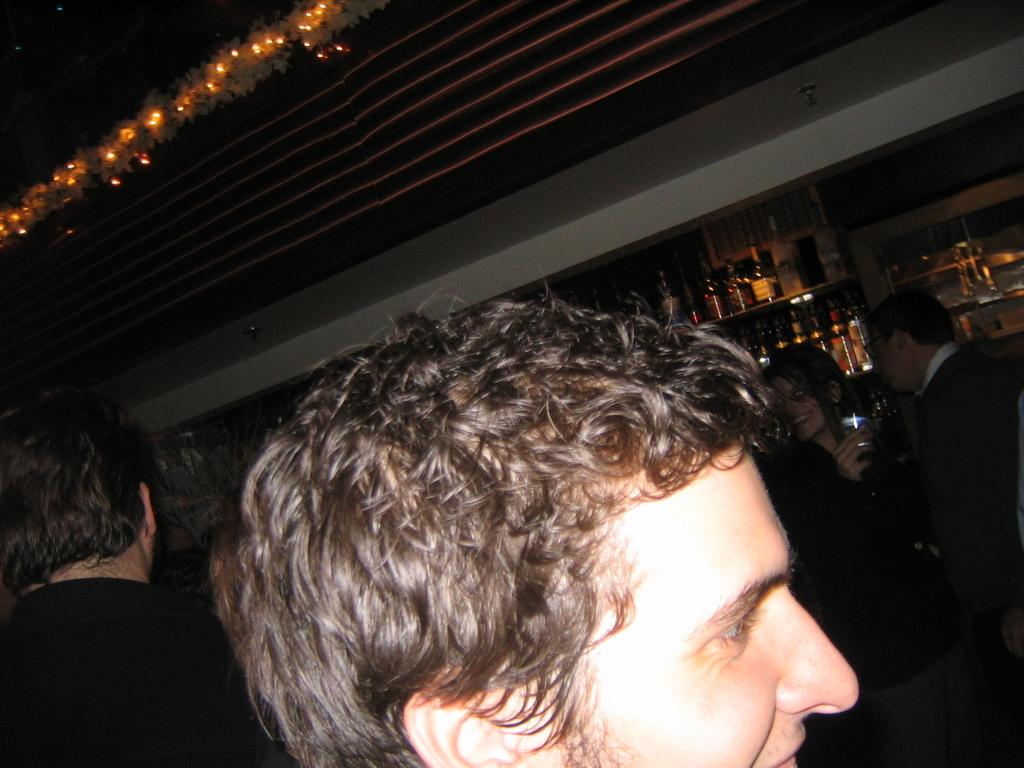Who is the main subject in the foreground of the image? There is a man in the foreground of the image. Can you describe the people behind the man? There are other people behind the man. What can be seen in the background of the image? There are many alcohol bottles on shelves in the background of the image. What type of cake is being destroyed in the image? There is no cake present in the image, nor is there any destruction taking place. 